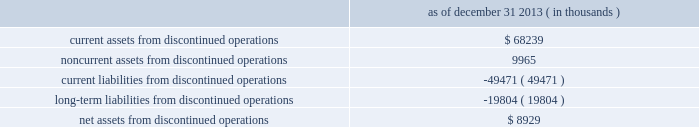Dish network corporation notes to consolidated financial statements - continued recorded as a decrease in 201cincome tax ( provision ) benefit , net 201d on our consolidated statements of operations and comprehensive income ( loss ) for the year ended december 31 , 2013 .
10 .
Discontinued operations as of december 31 , 2013 , blockbuster had ceased material operations .
The results of blockbuster are presented for all periods as discontinued operations in our consolidated financial statements .
During the years ended december 31 , 2013 and 2012 , the revenue from our discontinued operations was $ 503 million and $ 1.085 billion , respectively .
201cincome ( loss ) from discontinued operations , before income taxes 201d for the same periods was a loss of $ 54 million and $ 62 million , respectively .
In addition , 201cincome ( loss ) from discontinued operations , net of tax 201d for the same periods was a loss of $ 47 million and $ 37 million , respectively .
As of december 31 , 2013 , the net assets from our discontinued operations consisted of the following : december 31 , 2013 ( in thousands ) .
Blockbuster - domestic since the blockbuster acquisition , we continually evaluated the impact of certain factors , including , among other things , competitive pressures , the ability of significantly fewer company-owned domestic retail stores to continue to support corporate administrative costs , and other issues impacting the store-level financial performance of our company-owned domestic retail stores .
These factors , among others , previously led us to close a significant number of company-owned domestic retail stores during 2012 and 2013 .
On november 6 , 2013 , we announced that blockbuster would close all of its remaining company-owned domestic retail stores and discontinue the blockbuster by-mail dvd service .
As of december 31 , 2013 , blockbuster had ceased material operations .
Blockbuster 2013 mexico during the third quarter 2013 , we determined that our blockbuster operations in mexico ( 201cblockbuster mexico 201d ) were 201cheld for sale . 201d as a result , we recorded pre-tax impairment charges of $ 19 million related to exiting the business , which was recorded in 201cincome ( loss ) from discontinued operations , net of tax 201d on our consolidated statements of operations and comprehensive income ( loss ) for the year ended december 31 , 2013 .
On january 14 , 2014 , we completed the sale of blockbuster mexico .
Blockbuster uk administration on january 16 , 2013 , blockbuster entertainment limited and blockbuster gb limited , our blockbuster operating subsidiaries in the united kingdom , entered into administration proceedings in the united kingdom ( the 201cadministration 201d ) .
As a result of the administration , we wrote down the assets of all our blockbuster uk subsidiaries to their estimated net realizable value on our consolidated balance sheets as of december 31 , 2012 .
In total , we recorded charges of approximately $ 46 million on a pre-tax basis related to the administration , which was recorded in 201cincome ( loss ) from discontinued operations , net of tax 201d on our consolidated statements of operations and comprehensive income ( loss ) for the year ended december 31 , 2012. .
What is the tax expense related to discontinued operations in 2013? 
Computations: (54 - 47)
Answer: 7.0. 